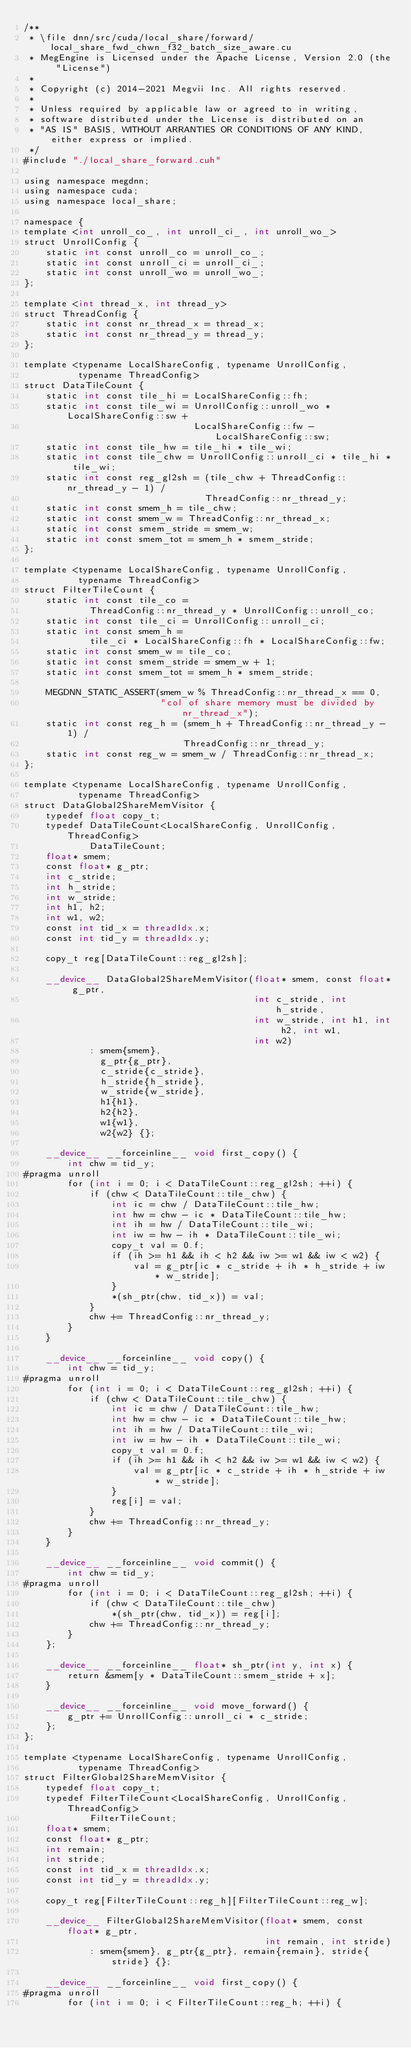<code> <loc_0><loc_0><loc_500><loc_500><_Cuda_>/**
 * \file dnn/src/cuda/local_share/forward/local_share_fwd_chwn_f32_batch_size_aware.cu
 * MegEngine is Licensed under the Apache License, Version 2.0 (the "License")
 *
 * Copyright (c) 2014-2021 Megvii Inc. All rights reserved.
 *
 * Unless required by applicable law or agreed to in writing,
 * software distributed under the License is distributed on an
 * "AS IS" BASIS, WITHOUT ARRANTIES OR CONDITIONS OF ANY KIND, either express or implied.
 */
#include "./local_share_forward.cuh"

using namespace megdnn;
using namespace cuda;
using namespace local_share;

namespace {
template <int unroll_co_, int unroll_ci_, int unroll_wo_>
struct UnrollConfig {
    static int const unroll_co = unroll_co_;
    static int const unroll_ci = unroll_ci_;
    static int const unroll_wo = unroll_wo_;
};

template <int thread_x, int thread_y>
struct ThreadConfig {
    static int const nr_thread_x = thread_x;
    static int const nr_thread_y = thread_y;
};

template <typename LocalShareConfig, typename UnrollConfig,
          typename ThreadConfig>
struct DataTileCount {
    static int const tile_hi = LocalShareConfig::fh;
    static int const tile_wi = UnrollConfig::unroll_wo * LocalShareConfig::sw +
                               LocalShareConfig::fw - LocalShareConfig::sw;
    static int const tile_hw = tile_hi * tile_wi;
    static int const tile_chw = UnrollConfig::unroll_ci * tile_hi * tile_wi;
    static int const reg_gl2sh = (tile_chw + ThreadConfig::nr_thread_y - 1) /
                                 ThreadConfig::nr_thread_y;
    static int const smem_h = tile_chw;
    static int const smem_w = ThreadConfig::nr_thread_x;
    static int const smem_stride = smem_w;
    static int const smem_tot = smem_h * smem_stride;
};

template <typename LocalShareConfig, typename UnrollConfig,
          typename ThreadConfig>
struct FilterTileCount {
    static int const tile_co =
            ThreadConfig::nr_thread_y * UnrollConfig::unroll_co;
    static int const tile_ci = UnrollConfig::unroll_ci;
    static int const smem_h =
            tile_ci * LocalShareConfig::fh * LocalShareConfig::fw;
    static int const smem_w = tile_co;
    static int const smem_stride = smem_w + 1;
    static int const smem_tot = smem_h * smem_stride;

    MEGDNN_STATIC_ASSERT(smem_w % ThreadConfig::nr_thread_x == 0,
                         "col of share memory must be divided by nr_thread_x");
    static int const reg_h = (smem_h + ThreadConfig::nr_thread_y - 1) /
                             ThreadConfig::nr_thread_y;
    static int const reg_w = smem_w / ThreadConfig::nr_thread_x;
};

template <typename LocalShareConfig, typename UnrollConfig,
          typename ThreadConfig>
struct DataGlobal2ShareMemVisitor {
    typedef float copy_t;
    typedef DataTileCount<LocalShareConfig, UnrollConfig, ThreadConfig>
            DataTileCount;
    float* smem;
    const float* g_ptr;
    int c_stride;
    int h_stride;
    int w_stride;
    int h1, h2;
    int w1, w2;
    const int tid_x = threadIdx.x;
    const int tid_y = threadIdx.y;

    copy_t reg[DataTileCount::reg_gl2sh];

    __device__ DataGlobal2ShareMemVisitor(float* smem, const float* g_ptr,
                                          int c_stride, int h_stride,
                                          int w_stride, int h1, int h2, int w1,
                                          int w2)
            : smem{smem},
              g_ptr{g_ptr},
              c_stride{c_stride},
              h_stride{h_stride},
              w_stride{w_stride},
              h1{h1},
              h2{h2},
              w1{w1},
              w2{w2} {};

    __device__ __forceinline__ void first_copy() {
        int chw = tid_y;
#pragma unroll
        for (int i = 0; i < DataTileCount::reg_gl2sh; ++i) {
            if (chw < DataTileCount::tile_chw) {
                int ic = chw / DataTileCount::tile_hw;
                int hw = chw - ic * DataTileCount::tile_hw;
                int ih = hw / DataTileCount::tile_wi;
                int iw = hw - ih * DataTileCount::tile_wi;
                copy_t val = 0.f;
                if (ih >= h1 && ih < h2 && iw >= w1 && iw < w2) {
                    val = g_ptr[ic * c_stride + ih * h_stride + iw * w_stride];
                }
                *(sh_ptr(chw, tid_x)) = val;
            }
            chw += ThreadConfig::nr_thread_y;
        }
    }

    __device__ __forceinline__ void copy() {
        int chw = tid_y;
#pragma unroll
        for (int i = 0; i < DataTileCount::reg_gl2sh; ++i) {
            if (chw < DataTileCount::tile_chw) {
                int ic = chw / DataTileCount::tile_hw;
                int hw = chw - ic * DataTileCount::tile_hw;
                int ih = hw / DataTileCount::tile_wi;
                int iw = hw - ih * DataTileCount::tile_wi;
                copy_t val = 0.f;
                if (ih >= h1 && ih < h2 && iw >= w1 && iw < w2) {
                    val = g_ptr[ic * c_stride + ih * h_stride + iw * w_stride];
                }
                reg[i] = val;
            }
            chw += ThreadConfig::nr_thread_y;
        }
    }

    __device__ __forceinline__ void commit() {
        int chw = tid_y;
#pragma unroll
        for (int i = 0; i < DataTileCount::reg_gl2sh; ++i) {
            if (chw < DataTileCount::tile_chw)
                *(sh_ptr(chw, tid_x)) = reg[i];
            chw += ThreadConfig::nr_thread_y;
        }
    };

    __device__ __forceinline__ float* sh_ptr(int y, int x) {
        return &smem[y * DataTileCount::smem_stride + x];
    }

    __device__ __forceinline__ void move_forward() {
        g_ptr += UnrollConfig::unroll_ci * c_stride;
    };
};

template <typename LocalShareConfig, typename UnrollConfig,
          typename ThreadConfig>
struct FilterGlobal2ShareMemVisitor {
    typedef float copy_t;
    typedef FilterTileCount<LocalShareConfig, UnrollConfig, ThreadConfig>
            FilterTileCount;
    float* smem;
    const float* g_ptr;
    int remain;
    int stride;
    const int tid_x = threadIdx.x;
    const int tid_y = threadIdx.y;

    copy_t reg[FilterTileCount::reg_h][FilterTileCount::reg_w];

    __device__ FilterGlobal2ShareMemVisitor(float* smem, const float* g_ptr,
                                            int remain, int stride)
            : smem{smem}, g_ptr{g_ptr}, remain{remain}, stride{stride} {};

    __device__ __forceinline__ void first_copy() {
#pragma unroll
        for (int i = 0; i < FilterTileCount::reg_h; ++i) {</code> 